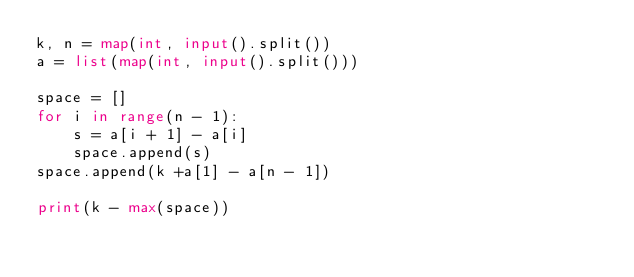<code> <loc_0><loc_0><loc_500><loc_500><_Python_>k, n = map(int, input().split())
a = list(map(int, input().split()))

space = []
for i in range(n - 1):
    s = a[i + 1] - a[i]
    space.append(s)
space.append(k +a[1] - a[n - 1])

print(k - max(space))
</code> 